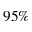<formula> <loc_0><loc_0><loc_500><loc_500>9 5 \%</formula> 